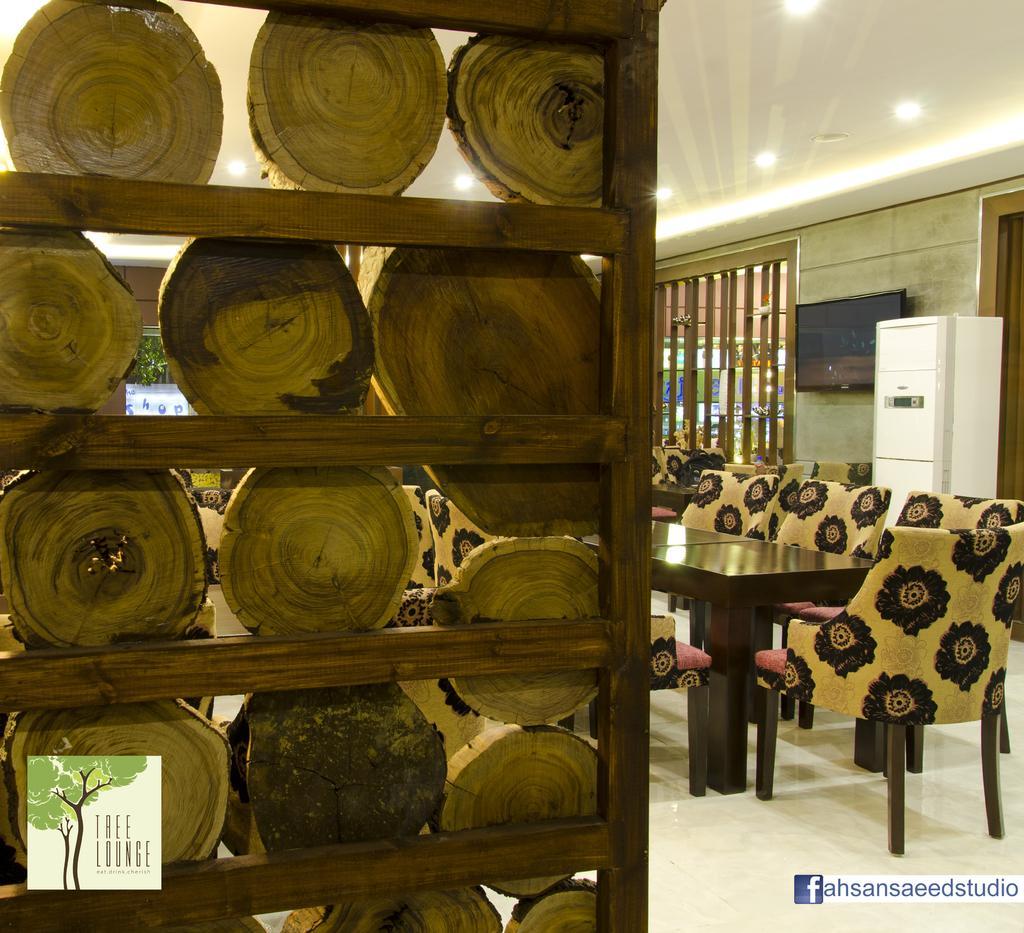Please provide a concise description of this image. In this image we can see table and chairs around it, television on the wall, wooden grills, electric lights to the roof, plants and wooden logs placed in the rack. 